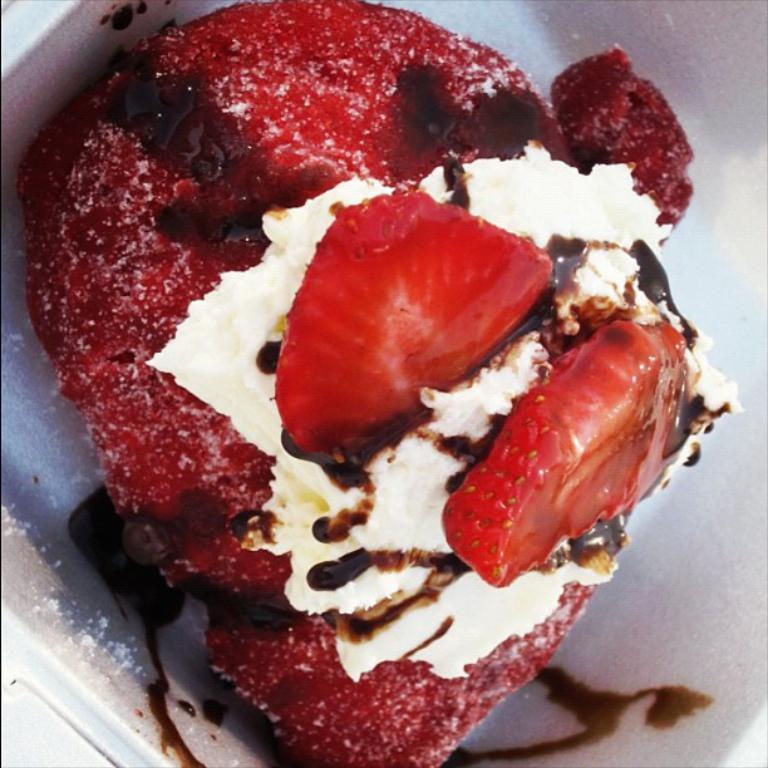In one or two sentences, can you explain what this image depicts? In the center of the image there is a food item in the plate. 